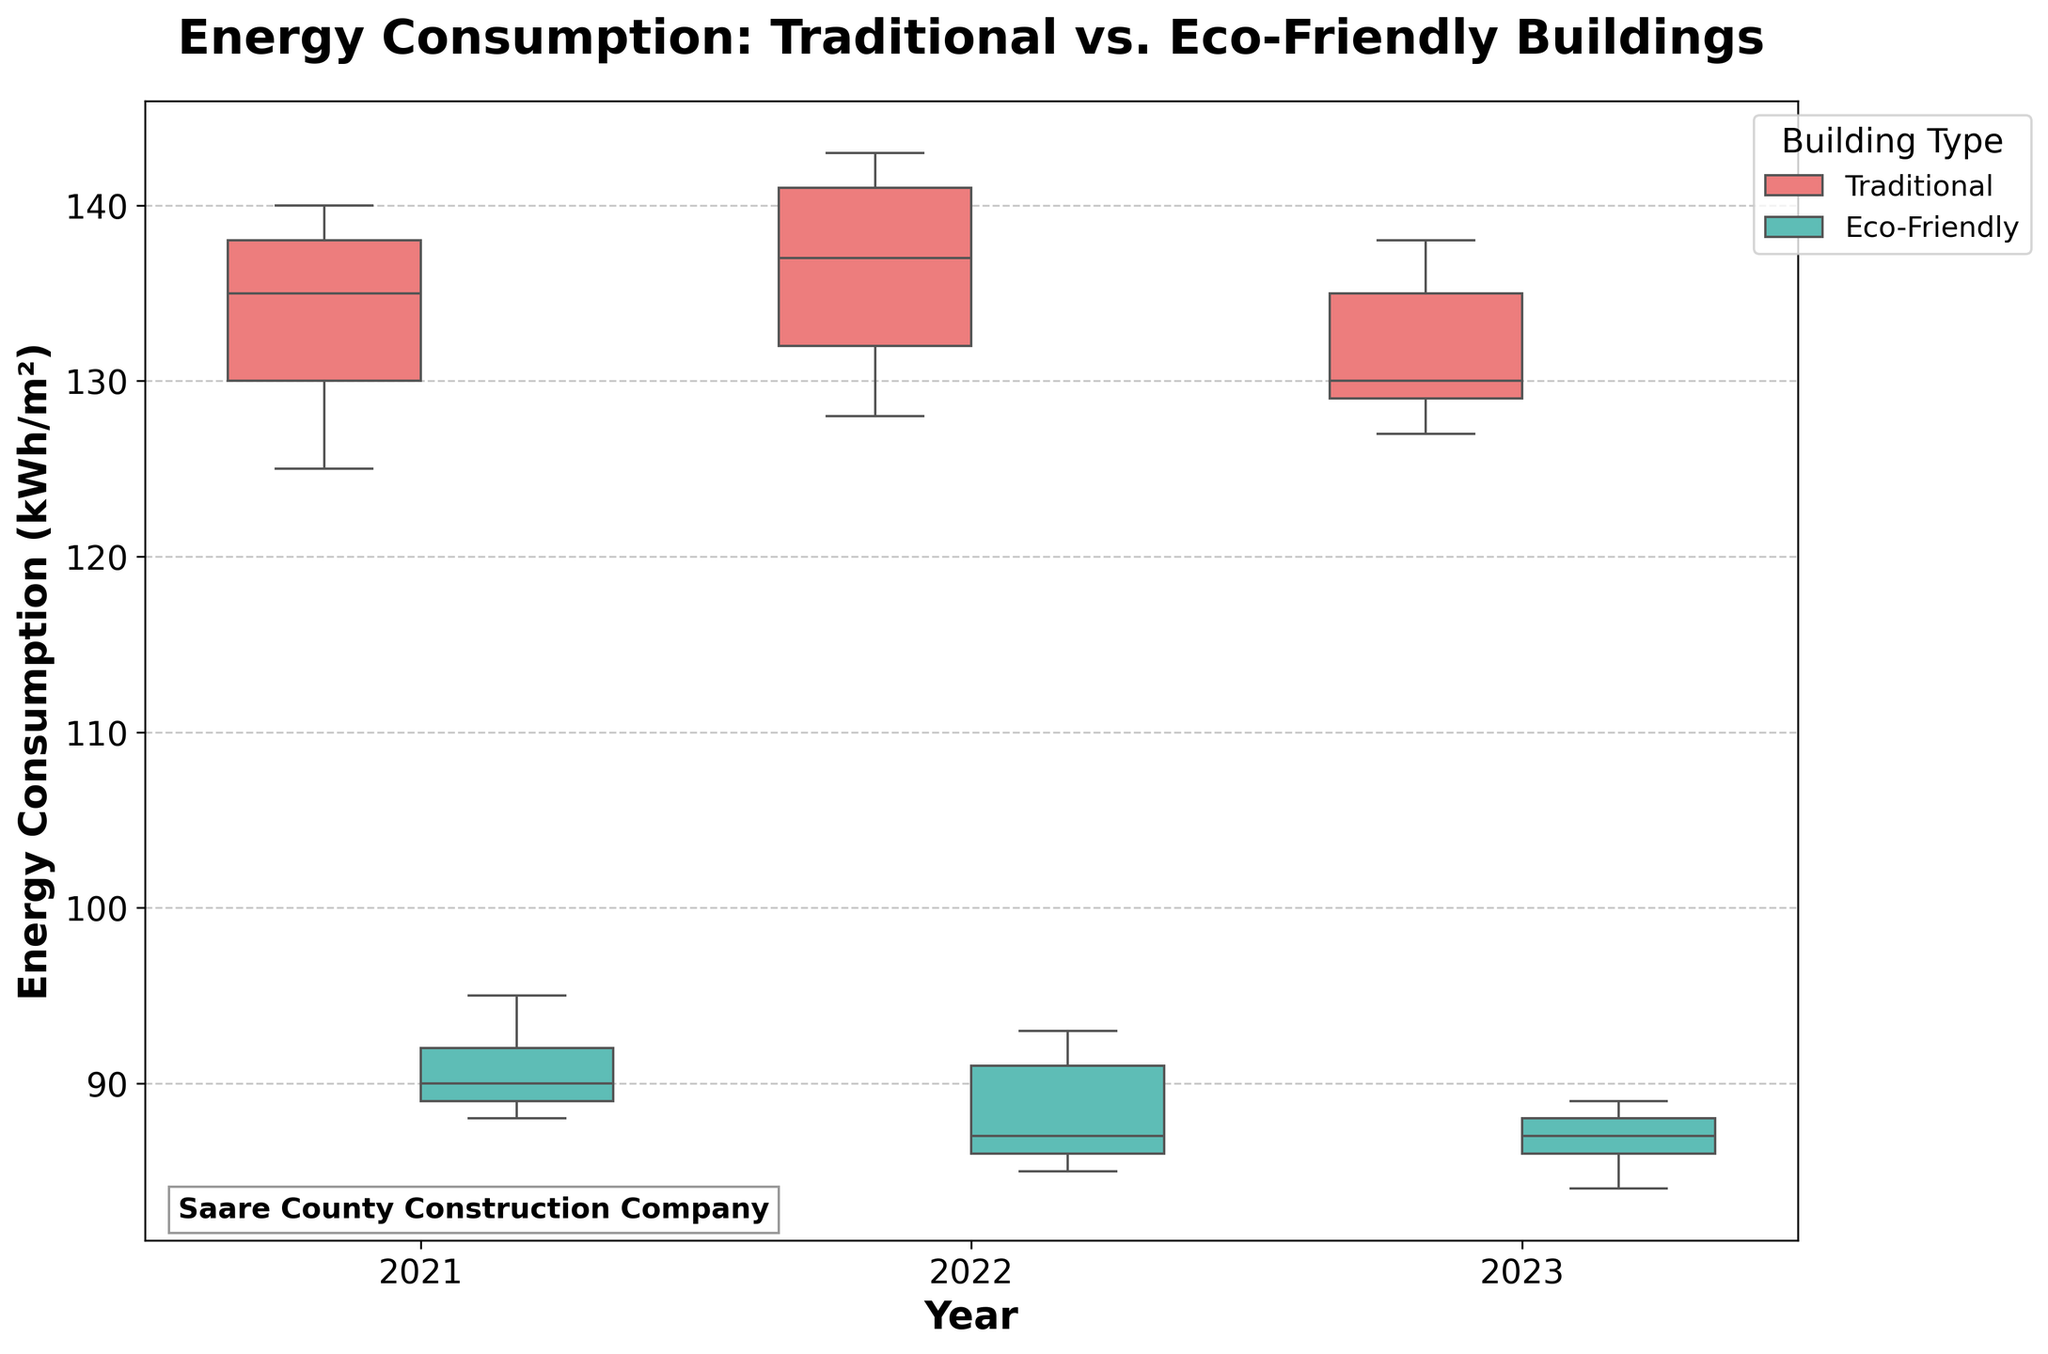What is the title of the plot? The title is prominently located at the top of the plot and reads "Energy Consumption: Traditional vs. Eco-Friendly Buildings". This is the main heading that describes what the plot is about.
Answer: Energy Consumption: Traditional vs. Eco-Friendly Buildings Which building type had lower energy consumption in 2021? Look at the box plots for 2021 and compare the two groups. The Eco-Friendly buildings have a lower range of energy consumption values than the Traditional buildings in 2021.
Answer: Eco-Friendly How is the energy consumption spread for Eco-Friendly buildings in 2022? Observing the box plot for Eco-Friendly buildings in 2022, the box represents the interquartile range (IQR) which is the middle 50% of the data. The ends of the box are at the first quartile (Q1) and the third quartile (Q3). The line inside the box shows the median. The whiskers extend to the minimum and maximum values that are not outliers.
Answer: Spread from 85 to 93 kWh/m² Which year's box plot for Traditional buildings has the highest median energy consumption? By checking the median line within each box plot for Traditional buildings across 2021, 2022, and 2023, the highest median energy consumption is observed.
Answer: 2022 What is the approximate median energy consumption for Eco-Friendly buildings in 2021? Find the median line within the box plot for the Eco-Friendly buildings in 2021. This line represents the median energy consumption.
Answer: Approximately 90 kWh/m² How does the range of energy consumption in 2021 for Traditional buildings compare to that of Eco-Friendly buildings? By evaluating the range from the minimum to maximum values (whiskers) of the box plots for both building types in 2021, traditional buildings have a wider range compared to Eco-Friendly buildings.
Answer: Wider for Traditional In which year is the energy consumption more consistent (less spread out) for Eco-Friendly buildings? Consistency can be assessed by the spread of the box, with a smaller IQR indicating more consistency. Compare the IQRs for Eco-Friendly buildings across the years.
Answer: 2023 Which building type exhibits a greater variability in energy consumption across the years shown? Variability can be examined by comparing the heights of the boxes and the lengths of the whiskers for each building type over the years. Traditional buildings show greater variability as their box plots have larger spreads.
Answer: Traditional Which year showed the highest maximum energy consumption for Traditional buildings? Look for the highest point on the whiskers or outliers for Traditional buildings in each year's box plot.
Answer: 2022 